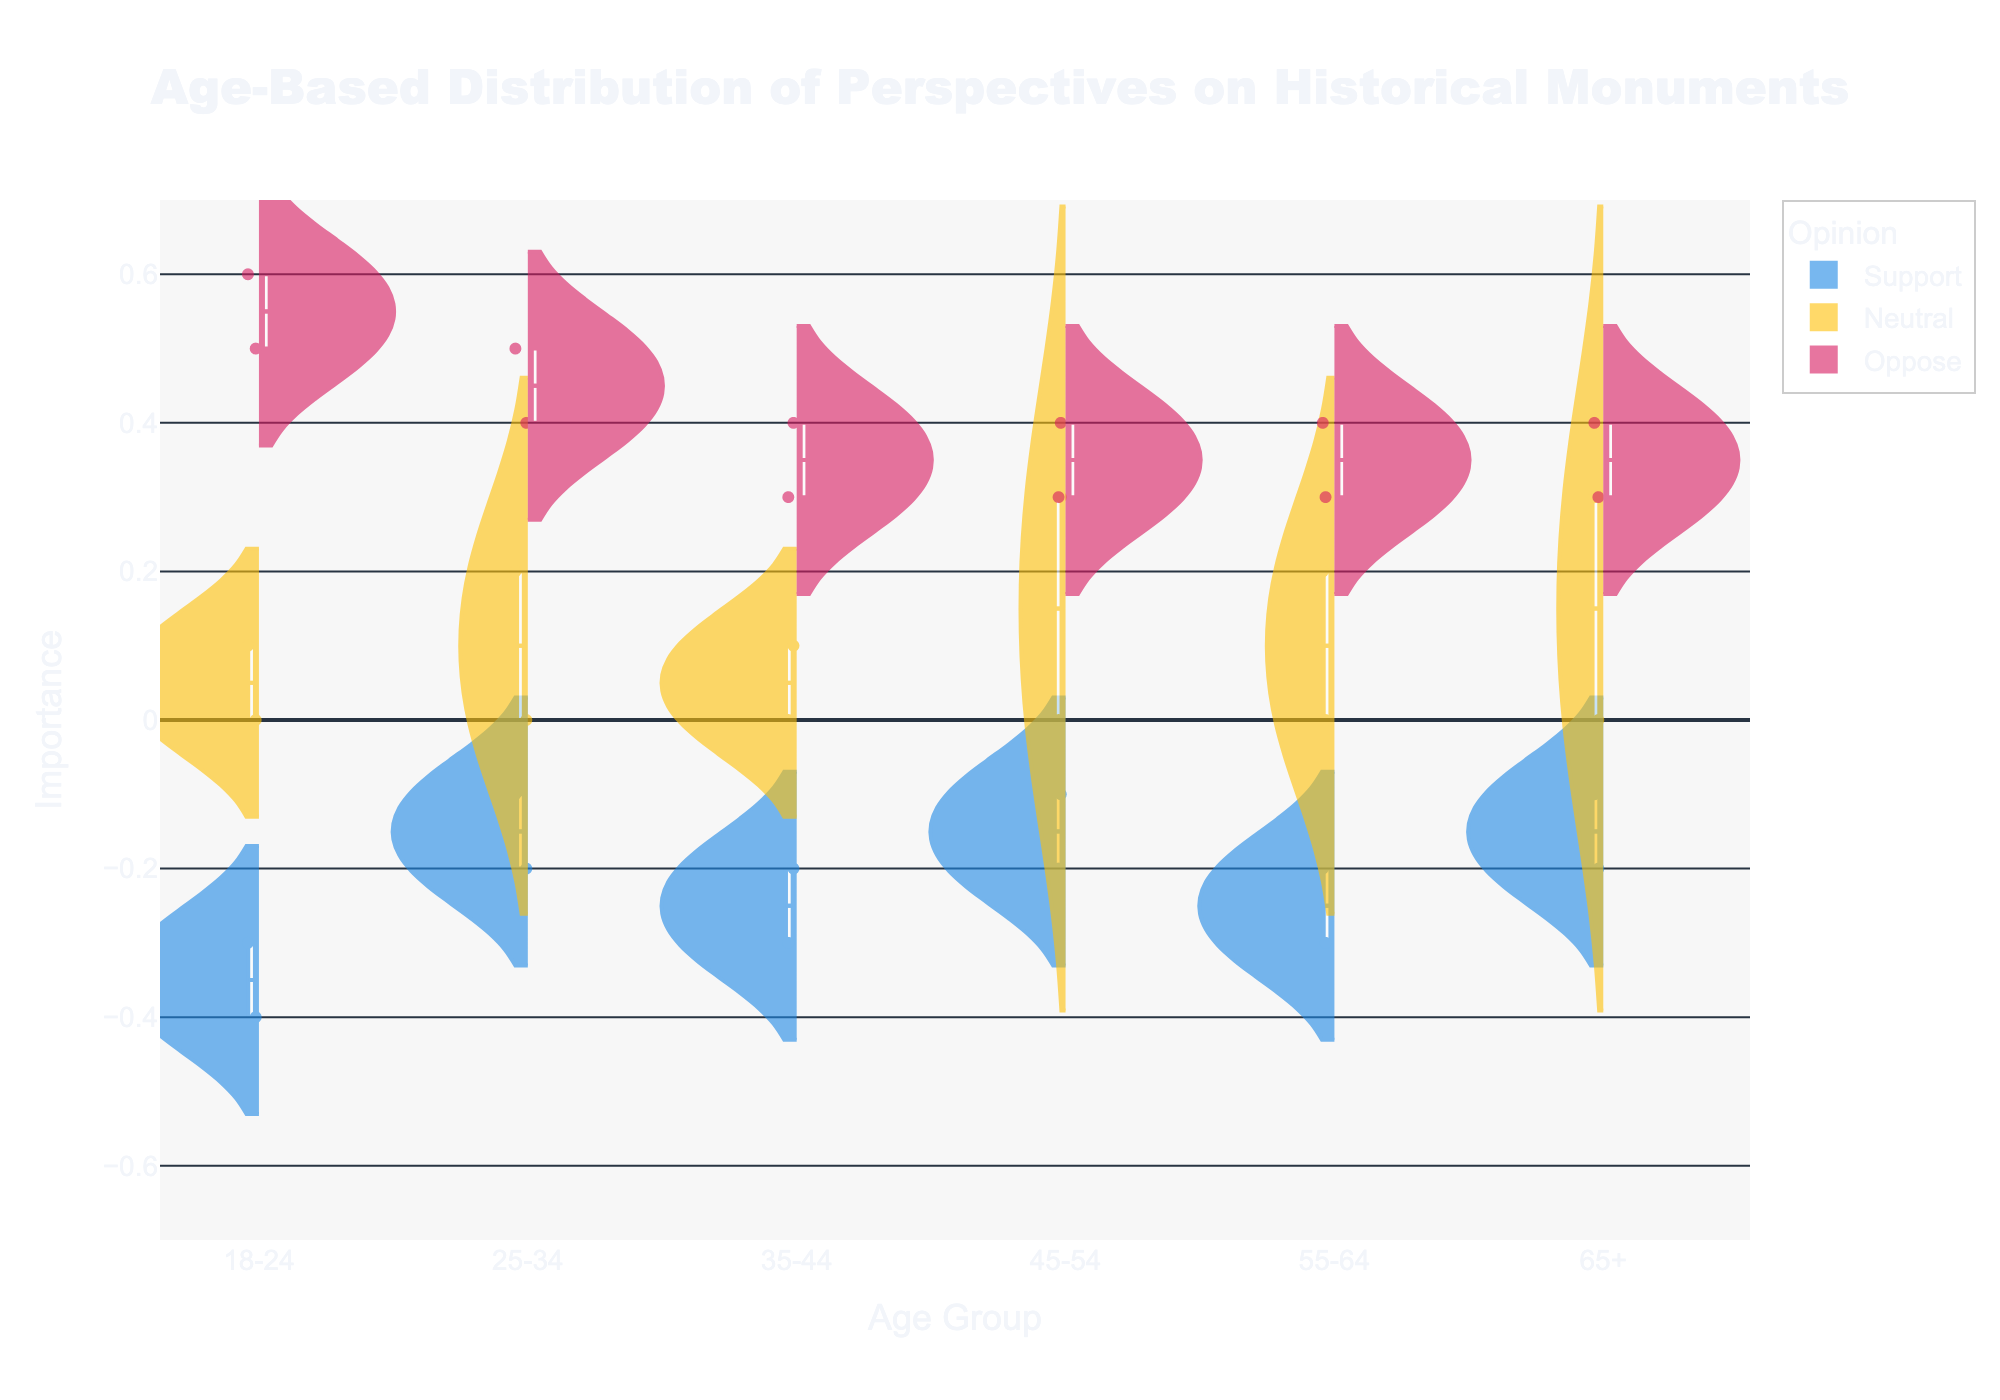What is the title of the figure? The title is positioned at the top of the figure. It reads "Age-Based Distribution of Perspectives on Historical Monuments."
Answer: Age-Based Distribution of Perspectives on Historical Monuments What does the y-axis represent in the figure? The y-axis label indicates that it represents "Importance." This axis shows values ranging from -0.7 to 0.7.
Answer: Importance How many age groups are represented in the figure? The x-axis contains tick labels that indicate different age groups. Counting these labels, there are six age groups represented.
Answer: Six Which opinion category is represented using the color blue? By looking at the legend provided in the figure, the color blue represents the "Support" category.
Answer: Support In the 18-24 age group, which opinion shows data points on the negative side of the y-axis? Observing the 18-24 age group in the figure, the data points in blue (representing "Support") are on the negative side of the y-axis (-0.3 and -0.4).
Answer: Support In the 45-54 age group, what is the range of the "Neutral" opinion category? For the 45-54 age group, locate the yellow "Neutral" category and observe the highest and lowest points. The range goes from 0 to 0.3.
Answer: 0 to 0.3 Which age group has the widest distribution for the "Oppose" opinion? Observing the "Oppose" category in pink across all age groups, the 18-24 group shows the widest spread, ranging from 0.5 to 0.6.
Answer: 18-24 Between the 25-34 and 35-44 age groups, which one has a higher mean value for the "Oppose" opinion? Examining the mean lines (horizontal lines within the violins) for "Oppose" in both groups, the 25-34 group has a mean around 0.45, while the 35-44 group has a mean around 0.35.
Answer: 25-34 Which age group shows the smallest distribution for the "Support" opinion? Observing the blue "Support" violins from all age groups, the 65+ age group has the smallest distribution, tightly clustered around -0.1 to -0.2.
Answer: 65+ 